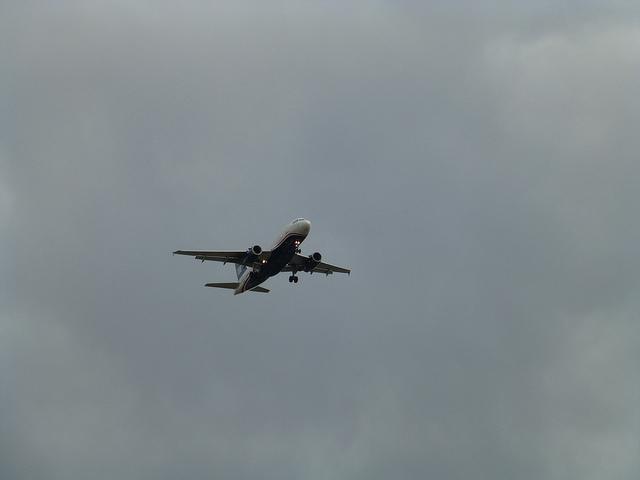How many planes are in the picture?
Give a very brief answer. 1. How many streams of smoke are there?
Give a very brief answer. 0. How many turbine engines are visible in this picture?
Give a very brief answer. 2. How many people are sitting on chair?
Give a very brief answer. 0. 